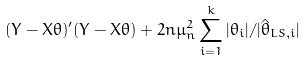<formula> <loc_0><loc_0><loc_500><loc_500>( Y - X \theta ) ^ { \prime } ( Y - X \theta ) + 2 n \mu _ { n } ^ { 2 } \sum _ { i = 1 } ^ { k } | \theta _ { i } | / | \hat { \theta } _ { L S , i } |</formula> 